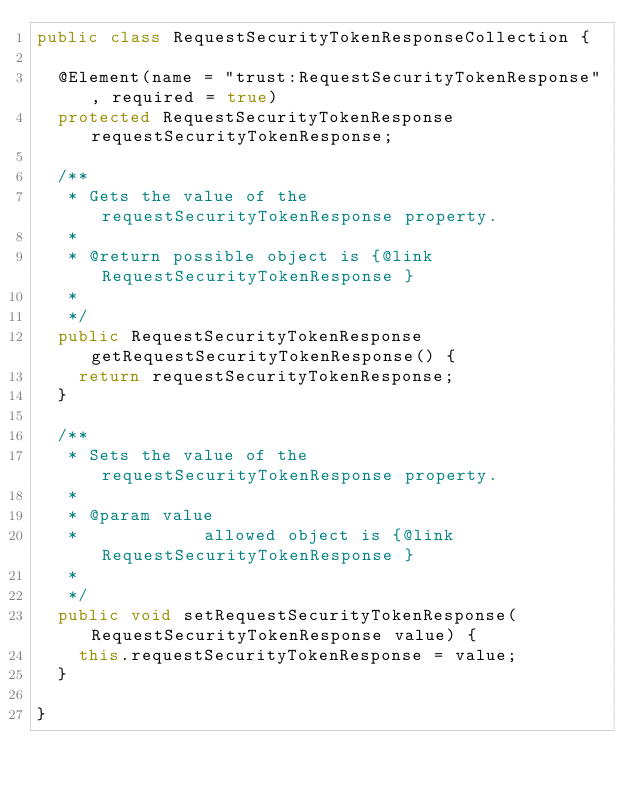Convert code to text. <code><loc_0><loc_0><loc_500><loc_500><_Java_>public class RequestSecurityTokenResponseCollection {

	@Element(name = "trust:RequestSecurityTokenResponse", required = true)
	protected RequestSecurityTokenResponse requestSecurityTokenResponse;

	/**
	 * Gets the value of the requestSecurityTokenResponse property.
	 * 
	 * @return possible object is {@link RequestSecurityTokenResponse }
	 * 
	 */
	public RequestSecurityTokenResponse getRequestSecurityTokenResponse() {
		return requestSecurityTokenResponse;
	}

	/**
	 * Sets the value of the requestSecurityTokenResponse property.
	 * 
	 * @param value
	 *            allowed object is {@link RequestSecurityTokenResponse }
	 * 
	 */
	public void setRequestSecurityTokenResponse(RequestSecurityTokenResponse value) {
		this.requestSecurityTokenResponse = value;
	}

}
</code> 